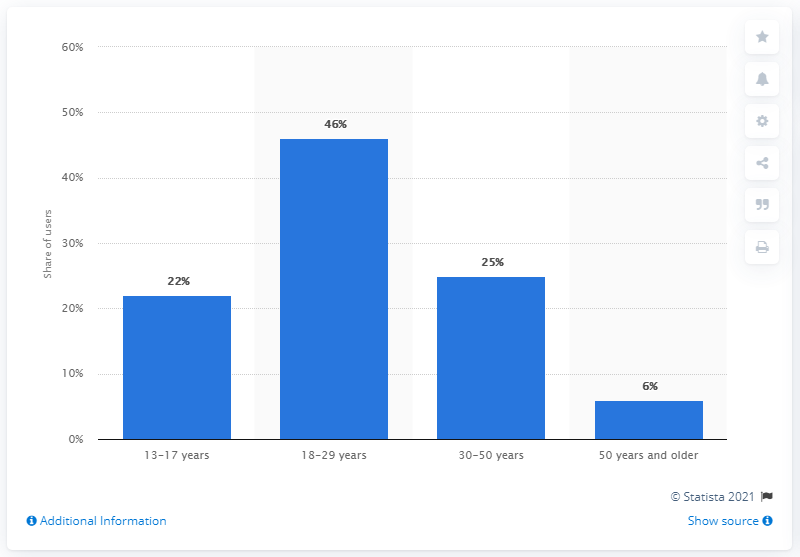List a handful of essential elements in this visual. According to data, approximately 46% of Pokemon GO users were between the ages of 18 and 29. 